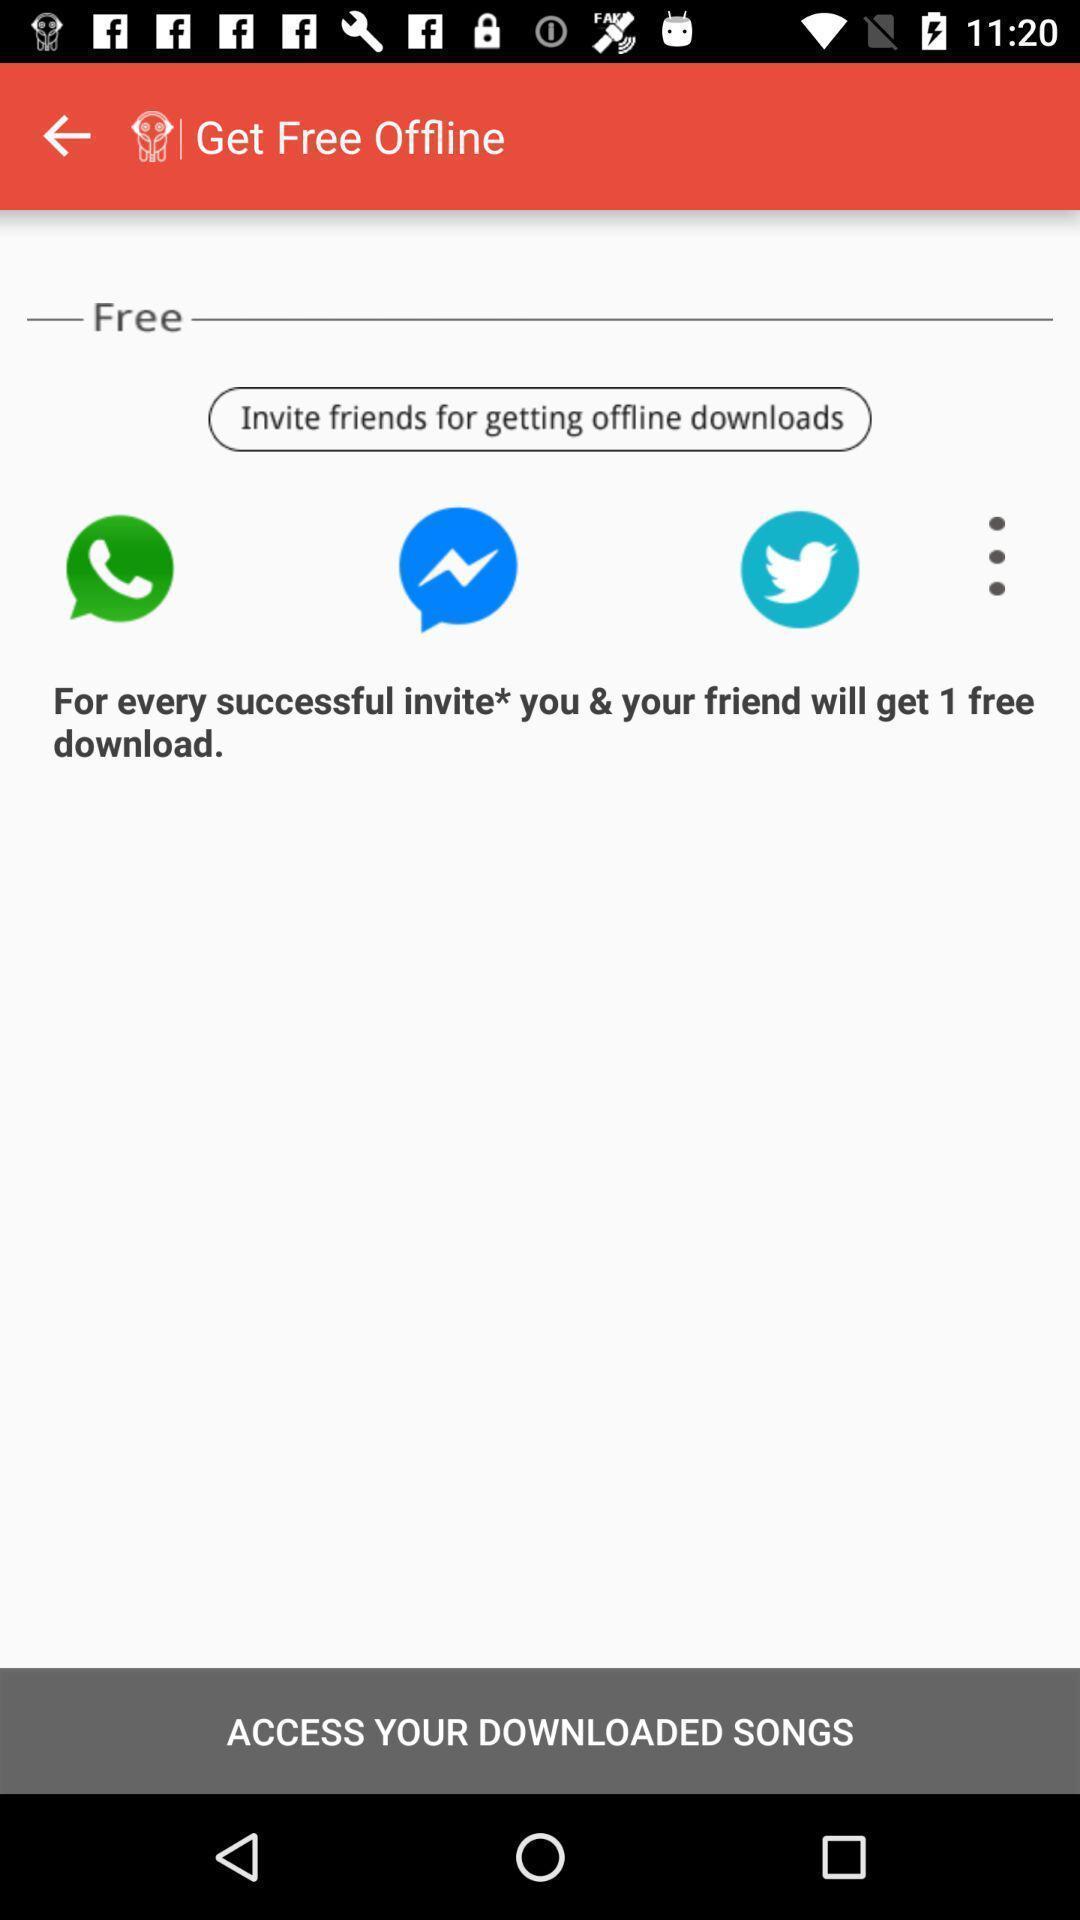What can you discern from this picture? Showing various options to invite friends for getting offline downloads. 